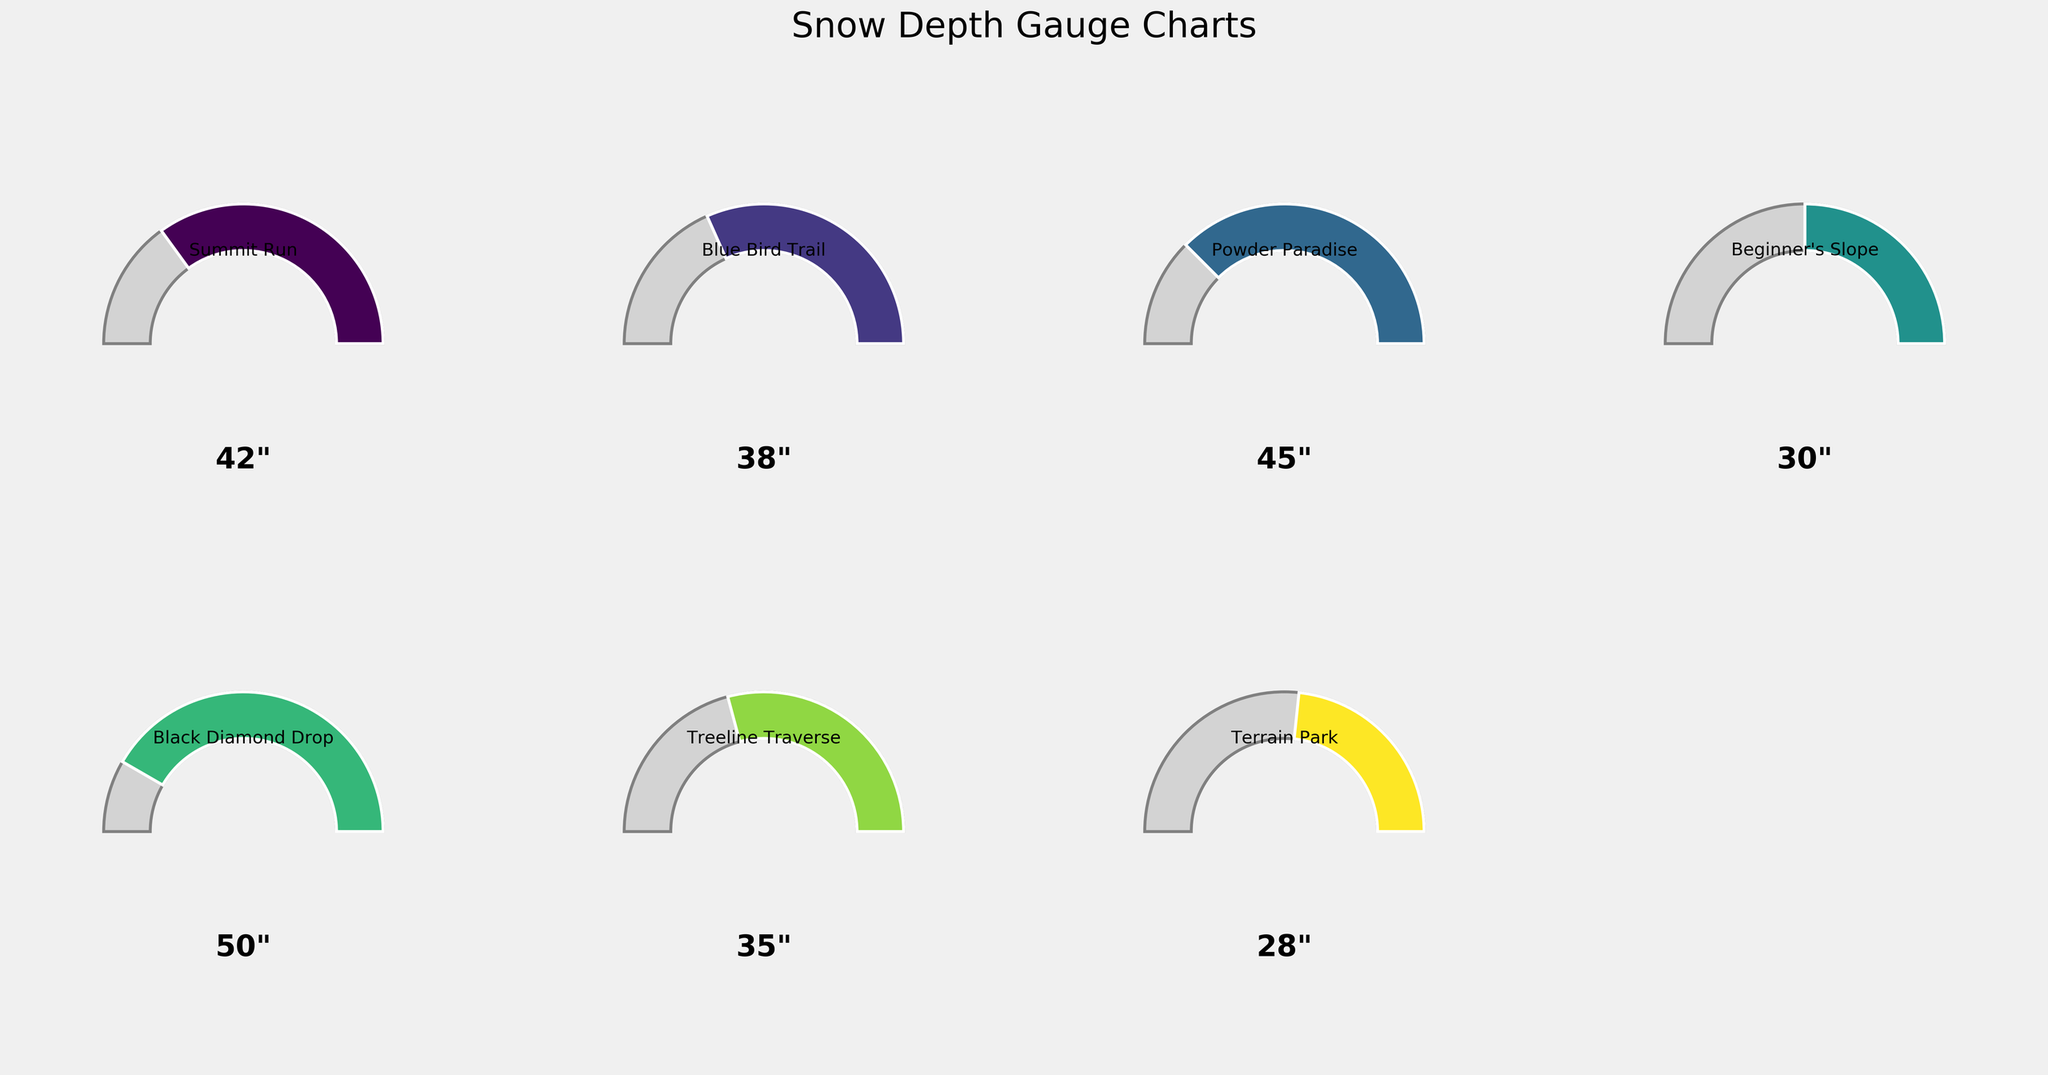which location has the highest snow depth? Look at the snow depth indicated at each gauge for different locations. "Black Diamond Drop" shows 50 inches, which is the highest.
Answer: Black Diamond Drop what is the minimum snow depth recorded? The smallest depth shown among the gauges is 28 inches, which corresponds to "Terrain Park."
Answer: 28 inches how many locations report snow depths over 40 inches? Check each gauge to see which ones have a depth greater than 40 inches. "Summit Run," "Powder Paradise," and "Black Diamond Drop" all have depths over 40 inches.
Answer: 3 which trail has the closest snow depth to the maximum depth of 60 inches? The gauge showing the highest depth without exceeding the maximum (60 inches) is "Black Diamond Drop" with 50 inches.
Answer: Black Diamond Drop what is the average snow depth for all the locations? Add up all the snow depths (42, 38, 45, 30, 50, 35, 28) and divide by the number of locations (7). The calculation is (42+38+45+30+50+35+28)/7 = 38 inches.
Answer: 38 inches is beginner's slope above or below the average snow depth? The average snow depth is 38 inches. "Beginner's Slope" has a depth of 30 inches, which is below that average.
Answer: Below which locations have snow depths within 5 inches of each other? Compare the depths: "Summit Run" (42 inches) and "Powder Paradise" (45 inches) are within 5 inches of each other; "Black Diamond Drop" (50 inches) and "Summit Run" (42 inches) are not within 5 inches; "Treeline Traverse" (35 inches) and "Blue Bird Trail" (38 inches) are within 5 inches of each other.
Answer: Summit Run and Powder Paradise, Treeline Traverse and Blue Bird Trail what percentage of the maximum depth does powder paradise have? "Powder Paradise" has a snow depth of 45 inches, and the maximum is 60 inches. The percentage is calculated as (45/60) * 100, which equals 75%.
Answer: 75% which gauge shows the smallest segment angle? The smallest segment angle corresponds to the smallest snow depth. "Terrain Park" shows 28 inches, which is the smallest segment.
Answer: Terrain Park 